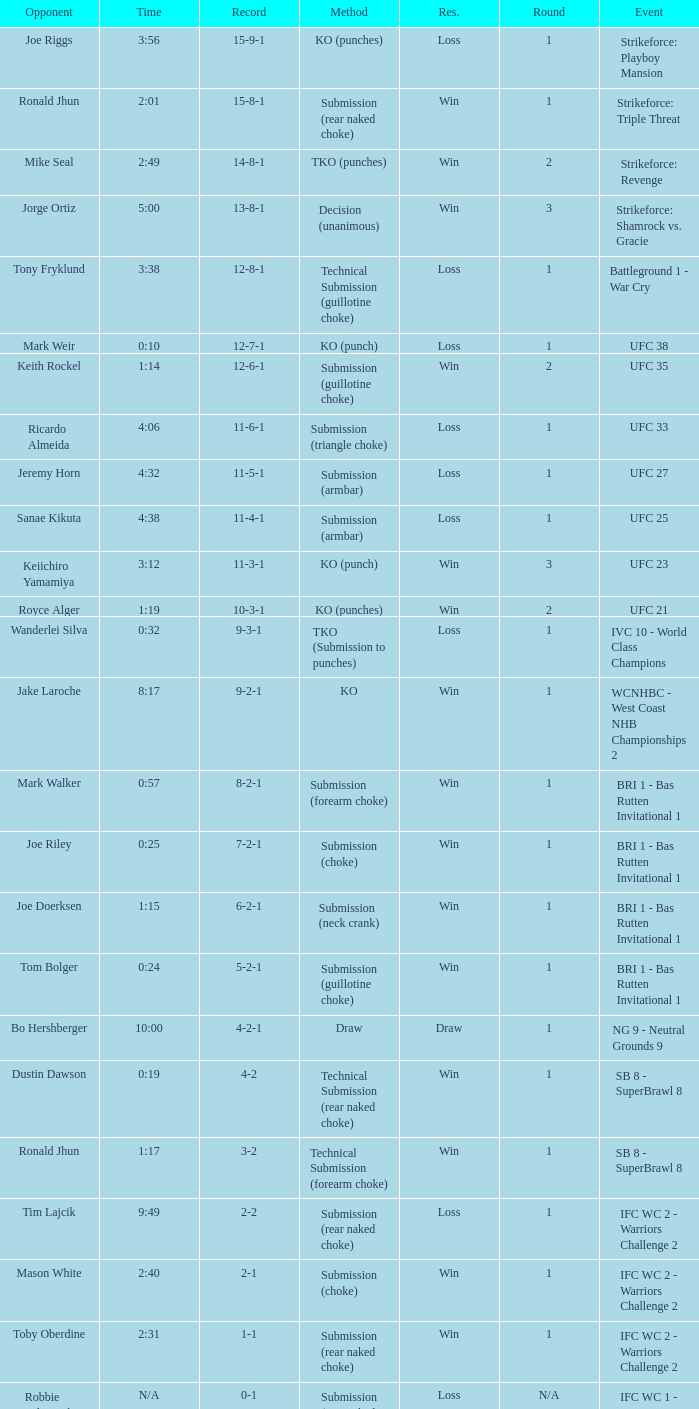Who was the opponent when the fight had a time of 0:10? Mark Weir. 